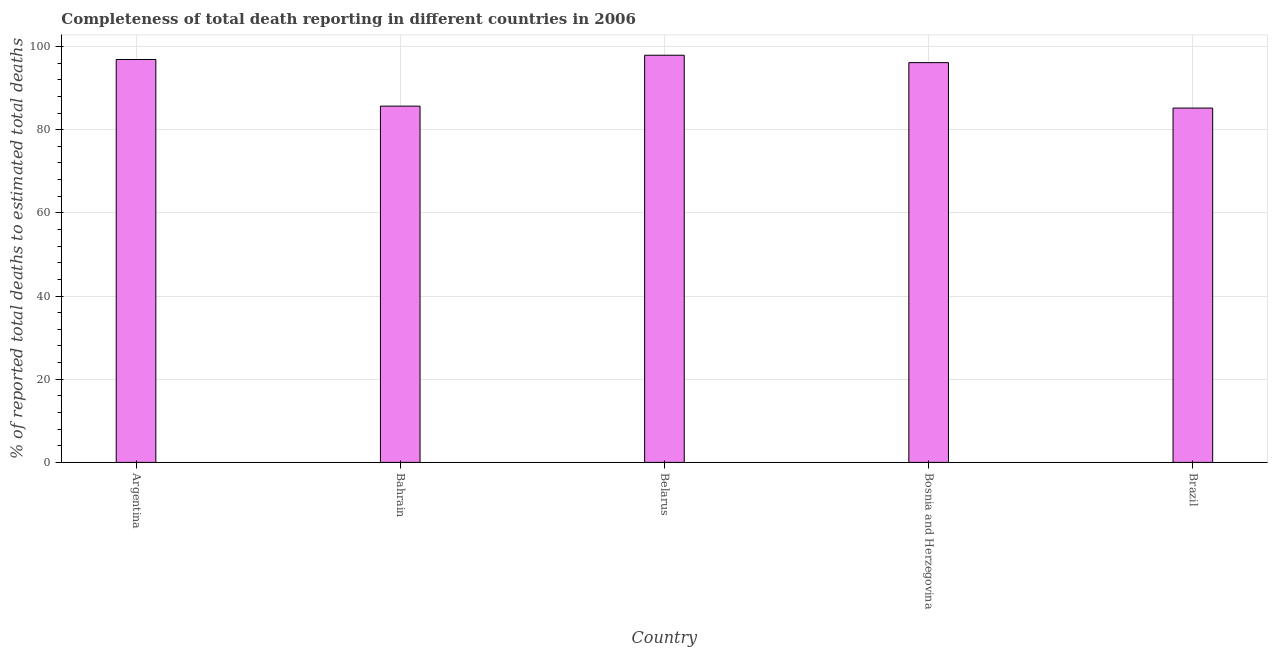Does the graph contain any zero values?
Your answer should be compact. No. Does the graph contain grids?
Make the answer very short. Yes. What is the title of the graph?
Provide a short and direct response. Completeness of total death reporting in different countries in 2006. What is the label or title of the X-axis?
Keep it short and to the point. Country. What is the label or title of the Y-axis?
Offer a very short reply. % of reported total deaths to estimated total deaths. What is the completeness of total death reports in Belarus?
Your answer should be very brief. 97.89. Across all countries, what is the maximum completeness of total death reports?
Make the answer very short. 97.89. Across all countries, what is the minimum completeness of total death reports?
Give a very brief answer. 85.19. In which country was the completeness of total death reports maximum?
Ensure brevity in your answer.  Belarus. What is the sum of the completeness of total death reports?
Your answer should be compact. 461.7. What is the difference between the completeness of total death reports in Argentina and Bahrain?
Keep it short and to the point. 11.21. What is the average completeness of total death reports per country?
Ensure brevity in your answer.  92.34. What is the median completeness of total death reports?
Keep it short and to the point. 96.11. In how many countries, is the completeness of total death reports greater than 24 %?
Your answer should be very brief. 5. What is the ratio of the completeness of total death reports in Argentina to that in Belarus?
Offer a terse response. 0.99. Is the completeness of total death reports in Bosnia and Herzegovina less than that in Brazil?
Your answer should be very brief. No. Is the difference between the completeness of total death reports in Bahrain and Belarus greater than the difference between any two countries?
Your answer should be very brief. No. What is the difference between the highest and the second highest completeness of total death reports?
Your response must be concise. 1.03. In how many countries, is the completeness of total death reports greater than the average completeness of total death reports taken over all countries?
Keep it short and to the point. 3. How many bars are there?
Offer a very short reply. 5. What is the difference between two consecutive major ticks on the Y-axis?
Give a very brief answer. 20. What is the % of reported total deaths to estimated total deaths in Argentina?
Your response must be concise. 96.86. What is the % of reported total deaths to estimated total deaths of Bahrain?
Your answer should be very brief. 85.65. What is the % of reported total deaths to estimated total deaths of Belarus?
Offer a terse response. 97.89. What is the % of reported total deaths to estimated total deaths of Bosnia and Herzegovina?
Provide a short and direct response. 96.11. What is the % of reported total deaths to estimated total deaths of Brazil?
Keep it short and to the point. 85.19. What is the difference between the % of reported total deaths to estimated total deaths in Argentina and Bahrain?
Your response must be concise. 11.21. What is the difference between the % of reported total deaths to estimated total deaths in Argentina and Belarus?
Keep it short and to the point. -1.03. What is the difference between the % of reported total deaths to estimated total deaths in Argentina and Bosnia and Herzegovina?
Your response must be concise. 0.75. What is the difference between the % of reported total deaths to estimated total deaths in Argentina and Brazil?
Your answer should be very brief. 11.67. What is the difference between the % of reported total deaths to estimated total deaths in Bahrain and Belarus?
Your response must be concise. -12.24. What is the difference between the % of reported total deaths to estimated total deaths in Bahrain and Bosnia and Herzegovina?
Offer a terse response. -10.46. What is the difference between the % of reported total deaths to estimated total deaths in Bahrain and Brazil?
Ensure brevity in your answer.  0.46. What is the difference between the % of reported total deaths to estimated total deaths in Belarus and Bosnia and Herzegovina?
Offer a very short reply. 1.78. What is the difference between the % of reported total deaths to estimated total deaths in Belarus and Brazil?
Ensure brevity in your answer.  12.7. What is the difference between the % of reported total deaths to estimated total deaths in Bosnia and Herzegovina and Brazil?
Your response must be concise. 10.92. What is the ratio of the % of reported total deaths to estimated total deaths in Argentina to that in Bahrain?
Ensure brevity in your answer.  1.13. What is the ratio of the % of reported total deaths to estimated total deaths in Argentina to that in Belarus?
Provide a short and direct response. 0.99. What is the ratio of the % of reported total deaths to estimated total deaths in Argentina to that in Bosnia and Herzegovina?
Your answer should be very brief. 1.01. What is the ratio of the % of reported total deaths to estimated total deaths in Argentina to that in Brazil?
Provide a short and direct response. 1.14. What is the ratio of the % of reported total deaths to estimated total deaths in Bahrain to that in Bosnia and Herzegovina?
Offer a terse response. 0.89. What is the ratio of the % of reported total deaths to estimated total deaths in Belarus to that in Brazil?
Give a very brief answer. 1.15. What is the ratio of the % of reported total deaths to estimated total deaths in Bosnia and Herzegovina to that in Brazil?
Provide a short and direct response. 1.13. 